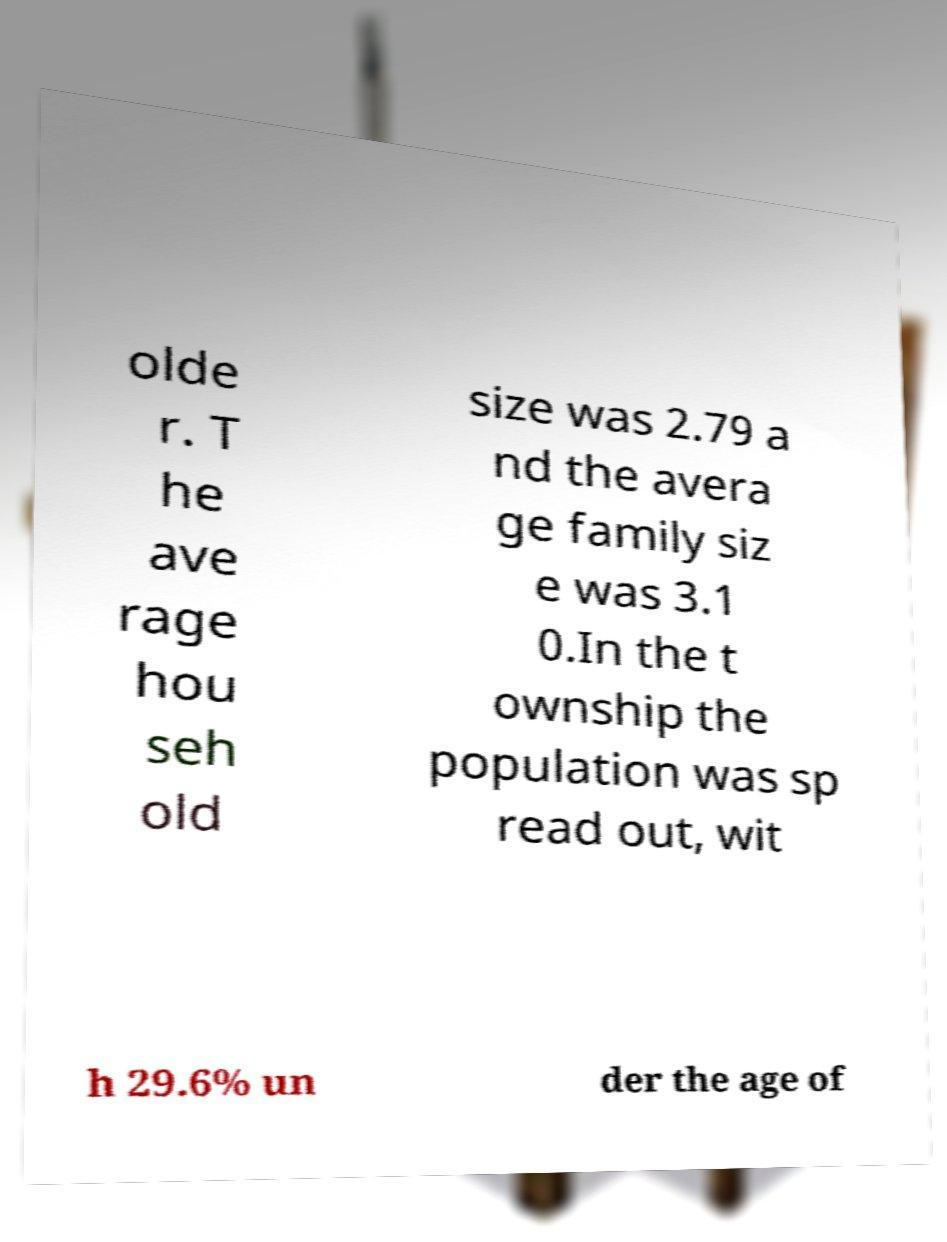Could you extract and type out the text from this image? olde r. T he ave rage hou seh old size was 2.79 a nd the avera ge family siz e was 3.1 0.In the t ownship the population was sp read out, wit h 29.6% un der the age of 